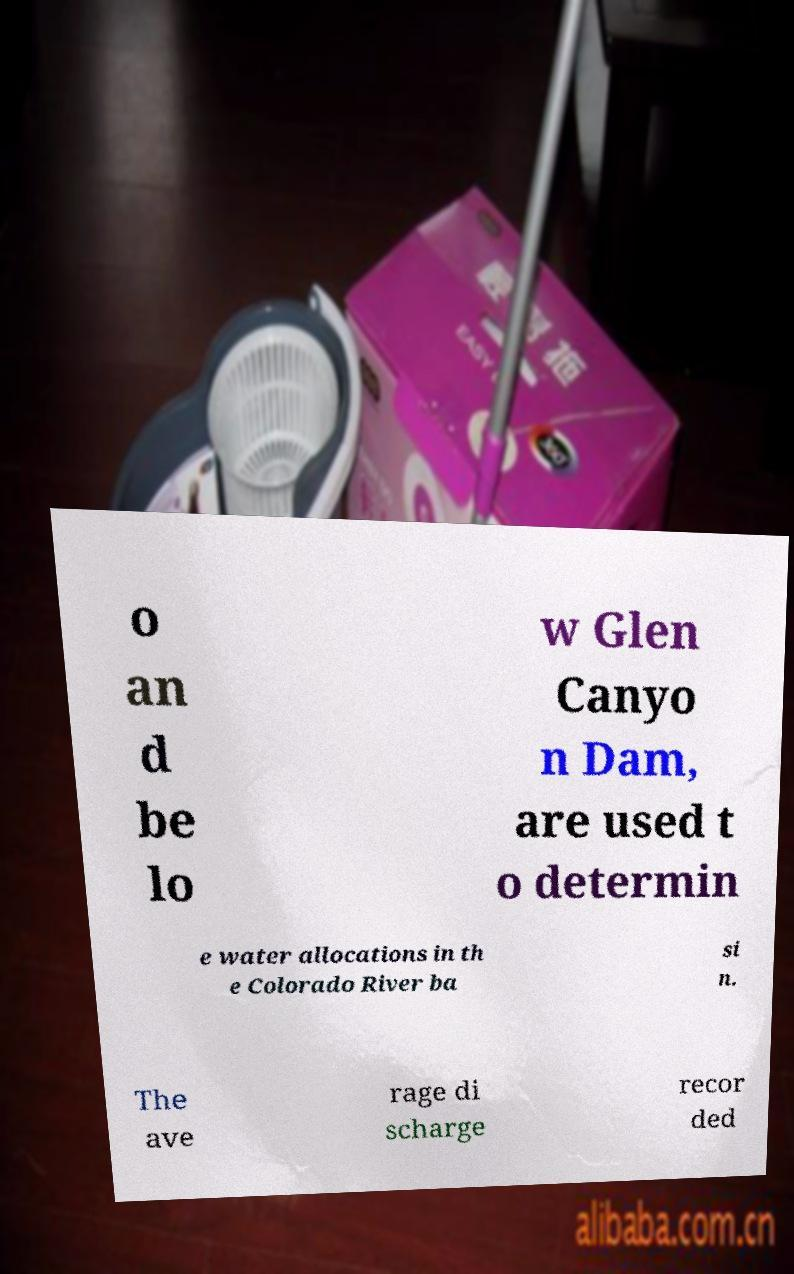Could you extract and type out the text from this image? o an d be lo w Glen Canyo n Dam, are used t o determin e water allocations in th e Colorado River ba si n. The ave rage di scharge recor ded 